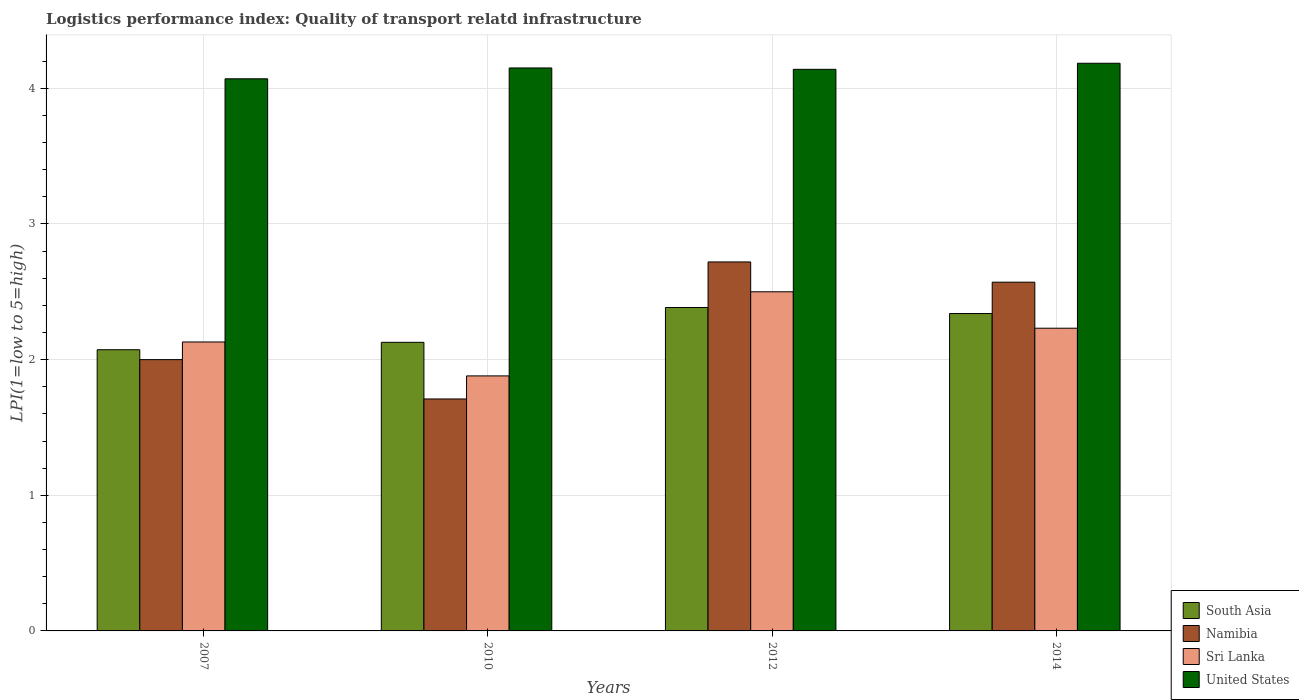Are the number of bars per tick equal to the number of legend labels?
Provide a short and direct response. Yes. Are the number of bars on each tick of the X-axis equal?
Your response must be concise. Yes. How many bars are there on the 1st tick from the right?
Give a very brief answer. 4. What is the logistics performance index in Sri Lanka in 2010?
Offer a very short reply. 1.88. Across all years, what is the minimum logistics performance index in United States?
Your answer should be compact. 4.07. In which year was the logistics performance index in Sri Lanka minimum?
Ensure brevity in your answer.  2010. What is the total logistics performance index in Namibia in the graph?
Provide a short and direct response. 9. What is the difference between the logistics performance index in Namibia in 2007 and that in 2014?
Provide a short and direct response. -0.57. What is the difference between the logistics performance index in South Asia in 2010 and the logistics performance index in Namibia in 2012?
Ensure brevity in your answer.  -0.59. What is the average logistics performance index in Sri Lanka per year?
Give a very brief answer. 2.19. In the year 2010, what is the difference between the logistics performance index in United States and logistics performance index in Namibia?
Ensure brevity in your answer.  2.44. In how many years, is the logistics performance index in Sri Lanka greater than 1.6?
Give a very brief answer. 4. What is the ratio of the logistics performance index in United States in 2007 to that in 2012?
Keep it short and to the point. 0.98. What is the difference between the highest and the second highest logistics performance index in Namibia?
Your answer should be compact. 0.15. What is the difference between the highest and the lowest logistics performance index in South Asia?
Ensure brevity in your answer.  0.31. Is the sum of the logistics performance index in Namibia in 2007 and 2012 greater than the maximum logistics performance index in United States across all years?
Provide a short and direct response. Yes. What does the 3rd bar from the right in 2007 represents?
Your answer should be very brief. Namibia. Is it the case that in every year, the sum of the logistics performance index in Namibia and logistics performance index in Sri Lanka is greater than the logistics performance index in South Asia?
Ensure brevity in your answer.  Yes. How many years are there in the graph?
Ensure brevity in your answer.  4. What is the difference between two consecutive major ticks on the Y-axis?
Keep it short and to the point. 1. How many legend labels are there?
Make the answer very short. 4. How are the legend labels stacked?
Your response must be concise. Vertical. What is the title of the graph?
Offer a very short reply. Logistics performance index: Quality of transport relatd infrastructure. What is the label or title of the X-axis?
Offer a terse response. Years. What is the label or title of the Y-axis?
Your response must be concise. LPI(1=low to 5=high). What is the LPI(1=low to 5=high) in South Asia in 2007?
Provide a short and direct response. 2.07. What is the LPI(1=low to 5=high) of Namibia in 2007?
Provide a short and direct response. 2. What is the LPI(1=low to 5=high) in Sri Lanka in 2007?
Provide a succinct answer. 2.13. What is the LPI(1=low to 5=high) of United States in 2007?
Ensure brevity in your answer.  4.07. What is the LPI(1=low to 5=high) in South Asia in 2010?
Your response must be concise. 2.13. What is the LPI(1=low to 5=high) in Namibia in 2010?
Offer a very short reply. 1.71. What is the LPI(1=low to 5=high) in Sri Lanka in 2010?
Keep it short and to the point. 1.88. What is the LPI(1=low to 5=high) in United States in 2010?
Keep it short and to the point. 4.15. What is the LPI(1=low to 5=high) of South Asia in 2012?
Your answer should be compact. 2.38. What is the LPI(1=low to 5=high) of Namibia in 2012?
Provide a short and direct response. 2.72. What is the LPI(1=low to 5=high) of Sri Lanka in 2012?
Your answer should be compact. 2.5. What is the LPI(1=low to 5=high) of United States in 2012?
Your response must be concise. 4.14. What is the LPI(1=low to 5=high) in South Asia in 2014?
Your answer should be very brief. 2.34. What is the LPI(1=low to 5=high) of Namibia in 2014?
Give a very brief answer. 2.57. What is the LPI(1=low to 5=high) of Sri Lanka in 2014?
Offer a terse response. 2.23. What is the LPI(1=low to 5=high) of United States in 2014?
Keep it short and to the point. 4.18. Across all years, what is the maximum LPI(1=low to 5=high) of South Asia?
Provide a short and direct response. 2.38. Across all years, what is the maximum LPI(1=low to 5=high) of Namibia?
Provide a short and direct response. 2.72. Across all years, what is the maximum LPI(1=low to 5=high) in Sri Lanka?
Provide a short and direct response. 2.5. Across all years, what is the maximum LPI(1=low to 5=high) in United States?
Provide a succinct answer. 4.18. Across all years, what is the minimum LPI(1=low to 5=high) of South Asia?
Your response must be concise. 2.07. Across all years, what is the minimum LPI(1=low to 5=high) in Namibia?
Keep it short and to the point. 1.71. Across all years, what is the minimum LPI(1=low to 5=high) of Sri Lanka?
Keep it short and to the point. 1.88. Across all years, what is the minimum LPI(1=low to 5=high) of United States?
Keep it short and to the point. 4.07. What is the total LPI(1=low to 5=high) of South Asia in the graph?
Ensure brevity in your answer.  8.92. What is the total LPI(1=low to 5=high) in Namibia in the graph?
Ensure brevity in your answer.  9. What is the total LPI(1=low to 5=high) of Sri Lanka in the graph?
Offer a very short reply. 8.74. What is the total LPI(1=low to 5=high) in United States in the graph?
Give a very brief answer. 16.54. What is the difference between the LPI(1=low to 5=high) of South Asia in 2007 and that in 2010?
Keep it short and to the point. -0.05. What is the difference between the LPI(1=low to 5=high) of Namibia in 2007 and that in 2010?
Offer a terse response. 0.29. What is the difference between the LPI(1=low to 5=high) of United States in 2007 and that in 2010?
Give a very brief answer. -0.08. What is the difference between the LPI(1=low to 5=high) in South Asia in 2007 and that in 2012?
Provide a short and direct response. -0.31. What is the difference between the LPI(1=low to 5=high) of Namibia in 2007 and that in 2012?
Offer a terse response. -0.72. What is the difference between the LPI(1=low to 5=high) of Sri Lanka in 2007 and that in 2012?
Your response must be concise. -0.37. What is the difference between the LPI(1=low to 5=high) of United States in 2007 and that in 2012?
Provide a succinct answer. -0.07. What is the difference between the LPI(1=low to 5=high) in South Asia in 2007 and that in 2014?
Give a very brief answer. -0.27. What is the difference between the LPI(1=low to 5=high) of Namibia in 2007 and that in 2014?
Provide a succinct answer. -0.57. What is the difference between the LPI(1=low to 5=high) of Sri Lanka in 2007 and that in 2014?
Offer a terse response. -0.1. What is the difference between the LPI(1=low to 5=high) of United States in 2007 and that in 2014?
Your answer should be compact. -0.11. What is the difference between the LPI(1=low to 5=high) of South Asia in 2010 and that in 2012?
Provide a short and direct response. -0.26. What is the difference between the LPI(1=low to 5=high) in Namibia in 2010 and that in 2012?
Ensure brevity in your answer.  -1.01. What is the difference between the LPI(1=low to 5=high) of Sri Lanka in 2010 and that in 2012?
Your response must be concise. -0.62. What is the difference between the LPI(1=low to 5=high) in United States in 2010 and that in 2012?
Offer a very short reply. 0.01. What is the difference between the LPI(1=low to 5=high) of South Asia in 2010 and that in 2014?
Provide a short and direct response. -0.21. What is the difference between the LPI(1=low to 5=high) of Namibia in 2010 and that in 2014?
Offer a terse response. -0.86. What is the difference between the LPI(1=low to 5=high) of Sri Lanka in 2010 and that in 2014?
Keep it short and to the point. -0.35. What is the difference between the LPI(1=low to 5=high) in United States in 2010 and that in 2014?
Provide a succinct answer. -0.03. What is the difference between the LPI(1=low to 5=high) in South Asia in 2012 and that in 2014?
Keep it short and to the point. 0.04. What is the difference between the LPI(1=low to 5=high) of Namibia in 2012 and that in 2014?
Give a very brief answer. 0.15. What is the difference between the LPI(1=low to 5=high) of Sri Lanka in 2012 and that in 2014?
Your response must be concise. 0.27. What is the difference between the LPI(1=low to 5=high) in United States in 2012 and that in 2014?
Make the answer very short. -0.04. What is the difference between the LPI(1=low to 5=high) of South Asia in 2007 and the LPI(1=low to 5=high) of Namibia in 2010?
Offer a terse response. 0.36. What is the difference between the LPI(1=low to 5=high) in South Asia in 2007 and the LPI(1=low to 5=high) in Sri Lanka in 2010?
Provide a short and direct response. 0.19. What is the difference between the LPI(1=low to 5=high) in South Asia in 2007 and the LPI(1=low to 5=high) in United States in 2010?
Provide a succinct answer. -2.08. What is the difference between the LPI(1=low to 5=high) in Namibia in 2007 and the LPI(1=low to 5=high) in Sri Lanka in 2010?
Keep it short and to the point. 0.12. What is the difference between the LPI(1=low to 5=high) of Namibia in 2007 and the LPI(1=low to 5=high) of United States in 2010?
Make the answer very short. -2.15. What is the difference between the LPI(1=low to 5=high) of Sri Lanka in 2007 and the LPI(1=low to 5=high) of United States in 2010?
Make the answer very short. -2.02. What is the difference between the LPI(1=low to 5=high) of South Asia in 2007 and the LPI(1=low to 5=high) of Namibia in 2012?
Ensure brevity in your answer.  -0.65. What is the difference between the LPI(1=low to 5=high) in South Asia in 2007 and the LPI(1=low to 5=high) in Sri Lanka in 2012?
Give a very brief answer. -0.43. What is the difference between the LPI(1=low to 5=high) of South Asia in 2007 and the LPI(1=low to 5=high) of United States in 2012?
Your response must be concise. -2.07. What is the difference between the LPI(1=low to 5=high) in Namibia in 2007 and the LPI(1=low to 5=high) in United States in 2012?
Provide a succinct answer. -2.14. What is the difference between the LPI(1=low to 5=high) of Sri Lanka in 2007 and the LPI(1=low to 5=high) of United States in 2012?
Your answer should be very brief. -2.01. What is the difference between the LPI(1=low to 5=high) of South Asia in 2007 and the LPI(1=low to 5=high) of Namibia in 2014?
Provide a succinct answer. -0.5. What is the difference between the LPI(1=low to 5=high) of South Asia in 2007 and the LPI(1=low to 5=high) of Sri Lanka in 2014?
Make the answer very short. -0.16. What is the difference between the LPI(1=low to 5=high) in South Asia in 2007 and the LPI(1=low to 5=high) in United States in 2014?
Keep it short and to the point. -2.11. What is the difference between the LPI(1=low to 5=high) in Namibia in 2007 and the LPI(1=low to 5=high) in Sri Lanka in 2014?
Make the answer very short. -0.23. What is the difference between the LPI(1=low to 5=high) of Namibia in 2007 and the LPI(1=low to 5=high) of United States in 2014?
Give a very brief answer. -2.18. What is the difference between the LPI(1=low to 5=high) of Sri Lanka in 2007 and the LPI(1=low to 5=high) of United States in 2014?
Offer a very short reply. -2.05. What is the difference between the LPI(1=low to 5=high) in South Asia in 2010 and the LPI(1=low to 5=high) in Namibia in 2012?
Provide a succinct answer. -0.59. What is the difference between the LPI(1=low to 5=high) of South Asia in 2010 and the LPI(1=low to 5=high) of Sri Lanka in 2012?
Your answer should be compact. -0.37. What is the difference between the LPI(1=low to 5=high) in South Asia in 2010 and the LPI(1=low to 5=high) in United States in 2012?
Your answer should be very brief. -2.01. What is the difference between the LPI(1=low to 5=high) in Namibia in 2010 and the LPI(1=low to 5=high) in Sri Lanka in 2012?
Provide a succinct answer. -0.79. What is the difference between the LPI(1=low to 5=high) of Namibia in 2010 and the LPI(1=low to 5=high) of United States in 2012?
Ensure brevity in your answer.  -2.43. What is the difference between the LPI(1=low to 5=high) in Sri Lanka in 2010 and the LPI(1=low to 5=high) in United States in 2012?
Offer a terse response. -2.26. What is the difference between the LPI(1=low to 5=high) of South Asia in 2010 and the LPI(1=low to 5=high) of Namibia in 2014?
Your answer should be very brief. -0.44. What is the difference between the LPI(1=low to 5=high) of South Asia in 2010 and the LPI(1=low to 5=high) of Sri Lanka in 2014?
Keep it short and to the point. -0.1. What is the difference between the LPI(1=low to 5=high) in South Asia in 2010 and the LPI(1=low to 5=high) in United States in 2014?
Your response must be concise. -2.06. What is the difference between the LPI(1=low to 5=high) in Namibia in 2010 and the LPI(1=low to 5=high) in Sri Lanka in 2014?
Make the answer very short. -0.52. What is the difference between the LPI(1=low to 5=high) of Namibia in 2010 and the LPI(1=low to 5=high) of United States in 2014?
Your answer should be very brief. -2.47. What is the difference between the LPI(1=low to 5=high) of Sri Lanka in 2010 and the LPI(1=low to 5=high) of United States in 2014?
Your answer should be very brief. -2.3. What is the difference between the LPI(1=low to 5=high) in South Asia in 2012 and the LPI(1=low to 5=high) in Namibia in 2014?
Your answer should be compact. -0.19. What is the difference between the LPI(1=low to 5=high) in South Asia in 2012 and the LPI(1=low to 5=high) in Sri Lanka in 2014?
Offer a terse response. 0.15. What is the difference between the LPI(1=low to 5=high) of South Asia in 2012 and the LPI(1=low to 5=high) of United States in 2014?
Offer a very short reply. -1.8. What is the difference between the LPI(1=low to 5=high) in Namibia in 2012 and the LPI(1=low to 5=high) in Sri Lanka in 2014?
Offer a terse response. 0.49. What is the difference between the LPI(1=low to 5=high) in Namibia in 2012 and the LPI(1=low to 5=high) in United States in 2014?
Your answer should be very brief. -1.46. What is the difference between the LPI(1=low to 5=high) of Sri Lanka in 2012 and the LPI(1=low to 5=high) of United States in 2014?
Give a very brief answer. -1.68. What is the average LPI(1=low to 5=high) in South Asia per year?
Your response must be concise. 2.23. What is the average LPI(1=low to 5=high) in Namibia per year?
Give a very brief answer. 2.25. What is the average LPI(1=low to 5=high) in Sri Lanka per year?
Give a very brief answer. 2.19. What is the average LPI(1=low to 5=high) of United States per year?
Make the answer very short. 4.14. In the year 2007, what is the difference between the LPI(1=low to 5=high) of South Asia and LPI(1=low to 5=high) of Namibia?
Ensure brevity in your answer.  0.07. In the year 2007, what is the difference between the LPI(1=low to 5=high) in South Asia and LPI(1=low to 5=high) in Sri Lanka?
Your response must be concise. -0.06. In the year 2007, what is the difference between the LPI(1=low to 5=high) of South Asia and LPI(1=low to 5=high) of United States?
Your answer should be compact. -2. In the year 2007, what is the difference between the LPI(1=low to 5=high) of Namibia and LPI(1=low to 5=high) of Sri Lanka?
Keep it short and to the point. -0.13. In the year 2007, what is the difference between the LPI(1=low to 5=high) in Namibia and LPI(1=low to 5=high) in United States?
Give a very brief answer. -2.07. In the year 2007, what is the difference between the LPI(1=low to 5=high) of Sri Lanka and LPI(1=low to 5=high) of United States?
Your answer should be compact. -1.94. In the year 2010, what is the difference between the LPI(1=low to 5=high) in South Asia and LPI(1=low to 5=high) in Namibia?
Offer a terse response. 0.42. In the year 2010, what is the difference between the LPI(1=low to 5=high) of South Asia and LPI(1=low to 5=high) of Sri Lanka?
Keep it short and to the point. 0.25. In the year 2010, what is the difference between the LPI(1=low to 5=high) of South Asia and LPI(1=low to 5=high) of United States?
Your answer should be very brief. -2.02. In the year 2010, what is the difference between the LPI(1=low to 5=high) of Namibia and LPI(1=low to 5=high) of Sri Lanka?
Provide a succinct answer. -0.17. In the year 2010, what is the difference between the LPI(1=low to 5=high) in Namibia and LPI(1=low to 5=high) in United States?
Offer a terse response. -2.44. In the year 2010, what is the difference between the LPI(1=low to 5=high) in Sri Lanka and LPI(1=low to 5=high) in United States?
Offer a very short reply. -2.27. In the year 2012, what is the difference between the LPI(1=low to 5=high) of South Asia and LPI(1=low to 5=high) of Namibia?
Ensure brevity in your answer.  -0.34. In the year 2012, what is the difference between the LPI(1=low to 5=high) of South Asia and LPI(1=low to 5=high) of Sri Lanka?
Give a very brief answer. -0.12. In the year 2012, what is the difference between the LPI(1=low to 5=high) of South Asia and LPI(1=low to 5=high) of United States?
Give a very brief answer. -1.76. In the year 2012, what is the difference between the LPI(1=low to 5=high) of Namibia and LPI(1=low to 5=high) of Sri Lanka?
Provide a short and direct response. 0.22. In the year 2012, what is the difference between the LPI(1=low to 5=high) of Namibia and LPI(1=low to 5=high) of United States?
Your response must be concise. -1.42. In the year 2012, what is the difference between the LPI(1=low to 5=high) in Sri Lanka and LPI(1=low to 5=high) in United States?
Provide a succinct answer. -1.64. In the year 2014, what is the difference between the LPI(1=low to 5=high) of South Asia and LPI(1=low to 5=high) of Namibia?
Give a very brief answer. -0.23. In the year 2014, what is the difference between the LPI(1=low to 5=high) in South Asia and LPI(1=low to 5=high) in Sri Lanka?
Your answer should be compact. 0.11. In the year 2014, what is the difference between the LPI(1=low to 5=high) in South Asia and LPI(1=low to 5=high) in United States?
Give a very brief answer. -1.84. In the year 2014, what is the difference between the LPI(1=low to 5=high) of Namibia and LPI(1=low to 5=high) of Sri Lanka?
Your response must be concise. 0.34. In the year 2014, what is the difference between the LPI(1=low to 5=high) of Namibia and LPI(1=low to 5=high) of United States?
Keep it short and to the point. -1.61. In the year 2014, what is the difference between the LPI(1=low to 5=high) of Sri Lanka and LPI(1=low to 5=high) of United States?
Make the answer very short. -1.95. What is the ratio of the LPI(1=low to 5=high) in South Asia in 2007 to that in 2010?
Offer a very short reply. 0.97. What is the ratio of the LPI(1=low to 5=high) of Namibia in 2007 to that in 2010?
Ensure brevity in your answer.  1.17. What is the ratio of the LPI(1=low to 5=high) in Sri Lanka in 2007 to that in 2010?
Provide a short and direct response. 1.13. What is the ratio of the LPI(1=low to 5=high) of United States in 2007 to that in 2010?
Provide a short and direct response. 0.98. What is the ratio of the LPI(1=low to 5=high) in South Asia in 2007 to that in 2012?
Your response must be concise. 0.87. What is the ratio of the LPI(1=low to 5=high) in Namibia in 2007 to that in 2012?
Offer a very short reply. 0.74. What is the ratio of the LPI(1=low to 5=high) of Sri Lanka in 2007 to that in 2012?
Offer a terse response. 0.85. What is the ratio of the LPI(1=low to 5=high) of United States in 2007 to that in 2012?
Make the answer very short. 0.98. What is the ratio of the LPI(1=low to 5=high) in South Asia in 2007 to that in 2014?
Keep it short and to the point. 0.89. What is the ratio of the LPI(1=low to 5=high) of Namibia in 2007 to that in 2014?
Ensure brevity in your answer.  0.78. What is the ratio of the LPI(1=low to 5=high) in Sri Lanka in 2007 to that in 2014?
Your response must be concise. 0.95. What is the ratio of the LPI(1=low to 5=high) of United States in 2007 to that in 2014?
Offer a very short reply. 0.97. What is the ratio of the LPI(1=low to 5=high) in South Asia in 2010 to that in 2012?
Give a very brief answer. 0.89. What is the ratio of the LPI(1=low to 5=high) of Namibia in 2010 to that in 2012?
Provide a succinct answer. 0.63. What is the ratio of the LPI(1=low to 5=high) in Sri Lanka in 2010 to that in 2012?
Your answer should be very brief. 0.75. What is the ratio of the LPI(1=low to 5=high) in South Asia in 2010 to that in 2014?
Keep it short and to the point. 0.91. What is the ratio of the LPI(1=low to 5=high) of Namibia in 2010 to that in 2014?
Keep it short and to the point. 0.67. What is the ratio of the LPI(1=low to 5=high) of Sri Lanka in 2010 to that in 2014?
Your answer should be compact. 0.84. What is the ratio of the LPI(1=low to 5=high) of United States in 2010 to that in 2014?
Offer a terse response. 0.99. What is the ratio of the LPI(1=low to 5=high) in South Asia in 2012 to that in 2014?
Your response must be concise. 1.02. What is the ratio of the LPI(1=low to 5=high) of Namibia in 2012 to that in 2014?
Your answer should be compact. 1.06. What is the ratio of the LPI(1=low to 5=high) in Sri Lanka in 2012 to that in 2014?
Offer a very short reply. 1.12. What is the ratio of the LPI(1=low to 5=high) of United States in 2012 to that in 2014?
Keep it short and to the point. 0.99. What is the difference between the highest and the second highest LPI(1=low to 5=high) in South Asia?
Your response must be concise. 0.04. What is the difference between the highest and the second highest LPI(1=low to 5=high) in Namibia?
Offer a terse response. 0.15. What is the difference between the highest and the second highest LPI(1=low to 5=high) in Sri Lanka?
Ensure brevity in your answer.  0.27. What is the difference between the highest and the second highest LPI(1=low to 5=high) of United States?
Give a very brief answer. 0.03. What is the difference between the highest and the lowest LPI(1=low to 5=high) in South Asia?
Keep it short and to the point. 0.31. What is the difference between the highest and the lowest LPI(1=low to 5=high) of Namibia?
Ensure brevity in your answer.  1.01. What is the difference between the highest and the lowest LPI(1=low to 5=high) of Sri Lanka?
Offer a terse response. 0.62. What is the difference between the highest and the lowest LPI(1=low to 5=high) of United States?
Give a very brief answer. 0.11. 